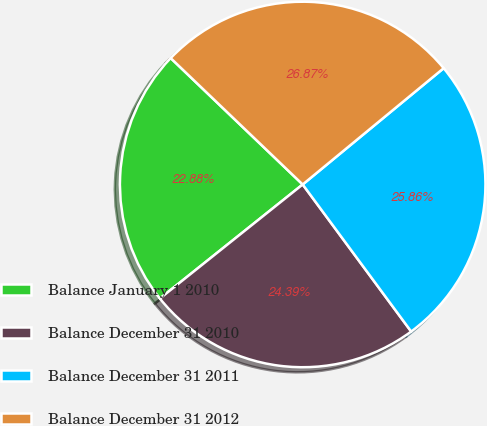Convert chart to OTSL. <chart><loc_0><loc_0><loc_500><loc_500><pie_chart><fcel>Balance January 1 2010<fcel>Balance December 31 2010<fcel>Balance December 31 2011<fcel>Balance December 31 2012<nl><fcel>22.88%<fcel>24.39%<fcel>25.86%<fcel>26.87%<nl></chart> 